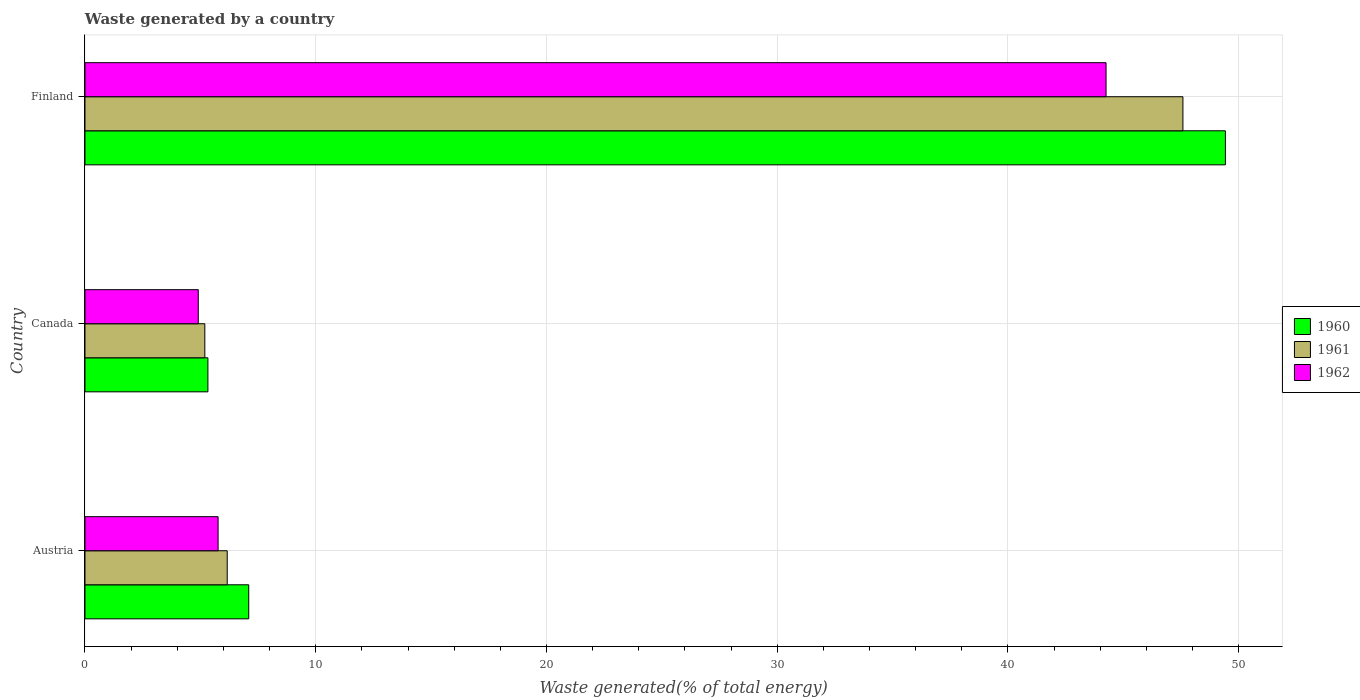How many different coloured bars are there?
Keep it short and to the point. 3. How many groups of bars are there?
Provide a succinct answer. 3. Are the number of bars on each tick of the Y-axis equal?
Your response must be concise. Yes. What is the label of the 3rd group of bars from the top?
Your answer should be very brief. Austria. In how many cases, is the number of bars for a given country not equal to the number of legend labels?
Give a very brief answer. 0. What is the total waste generated in 1960 in Finland?
Make the answer very short. 49.42. Across all countries, what is the maximum total waste generated in 1961?
Your answer should be very brief. 47.58. Across all countries, what is the minimum total waste generated in 1960?
Provide a succinct answer. 5.33. In which country was the total waste generated in 1960 maximum?
Your response must be concise. Finland. What is the total total waste generated in 1962 in the graph?
Offer a terse response. 54.93. What is the difference between the total waste generated in 1962 in Austria and that in Finland?
Keep it short and to the point. -38.48. What is the difference between the total waste generated in 1960 in Finland and the total waste generated in 1962 in Austria?
Offer a very short reply. 43.65. What is the average total waste generated in 1961 per country?
Your answer should be compact. 19.65. What is the difference between the total waste generated in 1962 and total waste generated in 1961 in Canada?
Your response must be concise. -0.28. What is the ratio of the total waste generated in 1961 in Canada to that in Finland?
Make the answer very short. 0.11. Is the total waste generated in 1962 in Canada less than that in Finland?
Provide a succinct answer. Yes. What is the difference between the highest and the second highest total waste generated in 1961?
Offer a very short reply. 41.42. What is the difference between the highest and the lowest total waste generated in 1961?
Ensure brevity in your answer.  42.39. In how many countries, is the total waste generated in 1962 greater than the average total waste generated in 1962 taken over all countries?
Your answer should be compact. 1. Is the sum of the total waste generated in 1962 in Austria and Finland greater than the maximum total waste generated in 1961 across all countries?
Keep it short and to the point. Yes. What does the 1st bar from the top in Finland represents?
Ensure brevity in your answer.  1962. Is it the case that in every country, the sum of the total waste generated in 1962 and total waste generated in 1960 is greater than the total waste generated in 1961?
Ensure brevity in your answer.  Yes. How many bars are there?
Offer a terse response. 9. Are all the bars in the graph horizontal?
Keep it short and to the point. Yes. How many countries are there in the graph?
Your answer should be compact. 3. What is the difference between two consecutive major ticks on the X-axis?
Your answer should be very brief. 10. Where does the legend appear in the graph?
Provide a succinct answer. Center right. How many legend labels are there?
Make the answer very short. 3. How are the legend labels stacked?
Ensure brevity in your answer.  Vertical. What is the title of the graph?
Provide a succinct answer. Waste generated by a country. Does "1972" appear as one of the legend labels in the graph?
Make the answer very short. No. What is the label or title of the X-axis?
Make the answer very short. Waste generated(% of total energy). What is the Waste generated(% of total energy) of 1960 in Austria?
Ensure brevity in your answer.  7.1. What is the Waste generated(% of total energy) in 1961 in Austria?
Provide a short and direct response. 6.16. What is the Waste generated(% of total energy) in 1962 in Austria?
Make the answer very short. 5.77. What is the Waste generated(% of total energy) of 1960 in Canada?
Your answer should be very brief. 5.33. What is the Waste generated(% of total energy) of 1961 in Canada?
Ensure brevity in your answer.  5.19. What is the Waste generated(% of total energy) of 1962 in Canada?
Your answer should be compact. 4.91. What is the Waste generated(% of total energy) in 1960 in Finland?
Your response must be concise. 49.42. What is the Waste generated(% of total energy) of 1961 in Finland?
Give a very brief answer. 47.58. What is the Waste generated(% of total energy) in 1962 in Finland?
Your answer should be very brief. 44.25. Across all countries, what is the maximum Waste generated(% of total energy) of 1960?
Make the answer very short. 49.42. Across all countries, what is the maximum Waste generated(% of total energy) of 1961?
Keep it short and to the point. 47.58. Across all countries, what is the maximum Waste generated(% of total energy) in 1962?
Offer a terse response. 44.25. Across all countries, what is the minimum Waste generated(% of total energy) of 1960?
Provide a succinct answer. 5.33. Across all countries, what is the minimum Waste generated(% of total energy) in 1961?
Offer a terse response. 5.19. Across all countries, what is the minimum Waste generated(% of total energy) in 1962?
Your answer should be compact. 4.91. What is the total Waste generated(% of total energy) in 1960 in the graph?
Give a very brief answer. 61.85. What is the total Waste generated(% of total energy) of 1961 in the graph?
Make the answer very short. 58.94. What is the total Waste generated(% of total energy) of 1962 in the graph?
Your answer should be very brief. 54.93. What is the difference between the Waste generated(% of total energy) in 1960 in Austria and that in Canada?
Your response must be concise. 1.77. What is the difference between the Waste generated(% of total energy) of 1961 in Austria and that in Canada?
Offer a terse response. 0.97. What is the difference between the Waste generated(% of total energy) in 1962 in Austria and that in Canada?
Ensure brevity in your answer.  0.86. What is the difference between the Waste generated(% of total energy) in 1960 in Austria and that in Finland?
Your answer should be very brief. -42.33. What is the difference between the Waste generated(% of total energy) in 1961 in Austria and that in Finland?
Keep it short and to the point. -41.42. What is the difference between the Waste generated(% of total energy) of 1962 in Austria and that in Finland?
Offer a terse response. -38.48. What is the difference between the Waste generated(% of total energy) in 1960 in Canada and that in Finland?
Offer a very short reply. -44.1. What is the difference between the Waste generated(% of total energy) in 1961 in Canada and that in Finland?
Provide a succinct answer. -42.39. What is the difference between the Waste generated(% of total energy) of 1962 in Canada and that in Finland?
Offer a very short reply. -39.34. What is the difference between the Waste generated(% of total energy) in 1960 in Austria and the Waste generated(% of total energy) in 1961 in Canada?
Make the answer very short. 1.9. What is the difference between the Waste generated(% of total energy) of 1960 in Austria and the Waste generated(% of total energy) of 1962 in Canada?
Offer a very short reply. 2.19. What is the difference between the Waste generated(% of total energy) in 1961 in Austria and the Waste generated(% of total energy) in 1962 in Canada?
Your response must be concise. 1.25. What is the difference between the Waste generated(% of total energy) of 1960 in Austria and the Waste generated(% of total energy) of 1961 in Finland?
Provide a succinct answer. -40.48. What is the difference between the Waste generated(% of total energy) of 1960 in Austria and the Waste generated(% of total energy) of 1962 in Finland?
Provide a short and direct response. -37.15. What is the difference between the Waste generated(% of total energy) of 1961 in Austria and the Waste generated(% of total energy) of 1962 in Finland?
Ensure brevity in your answer.  -38.09. What is the difference between the Waste generated(% of total energy) of 1960 in Canada and the Waste generated(% of total energy) of 1961 in Finland?
Your answer should be compact. -42.25. What is the difference between the Waste generated(% of total energy) in 1960 in Canada and the Waste generated(% of total energy) in 1962 in Finland?
Offer a terse response. -38.92. What is the difference between the Waste generated(% of total energy) of 1961 in Canada and the Waste generated(% of total energy) of 1962 in Finland?
Provide a succinct answer. -39.06. What is the average Waste generated(% of total energy) of 1960 per country?
Ensure brevity in your answer.  20.62. What is the average Waste generated(% of total energy) of 1961 per country?
Your answer should be very brief. 19.65. What is the average Waste generated(% of total energy) in 1962 per country?
Ensure brevity in your answer.  18.31. What is the difference between the Waste generated(% of total energy) in 1960 and Waste generated(% of total energy) in 1961 in Austria?
Make the answer very short. 0.93. What is the difference between the Waste generated(% of total energy) of 1960 and Waste generated(% of total energy) of 1962 in Austria?
Provide a short and direct response. 1.33. What is the difference between the Waste generated(% of total energy) of 1961 and Waste generated(% of total energy) of 1962 in Austria?
Offer a terse response. 0.4. What is the difference between the Waste generated(% of total energy) in 1960 and Waste generated(% of total energy) in 1961 in Canada?
Offer a terse response. 0.13. What is the difference between the Waste generated(% of total energy) of 1960 and Waste generated(% of total energy) of 1962 in Canada?
Ensure brevity in your answer.  0.42. What is the difference between the Waste generated(% of total energy) of 1961 and Waste generated(% of total energy) of 1962 in Canada?
Your answer should be compact. 0.28. What is the difference between the Waste generated(% of total energy) in 1960 and Waste generated(% of total energy) in 1961 in Finland?
Your response must be concise. 1.84. What is the difference between the Waste generated(% of total energy) of 1960 and Waste generated(% of total energy) of 1962 in Finland?
Make the answer very short. 5.17. What is the difference between the Waste generated(% of total energy) in 1961 and Waste generated(% of total energy) in 1962 in Finland?
Your answer should be compact. 3.33. What is the ratio of the Waste generated(% of total energy) in 1960 in Austria to that in Canada?
Your answer should be compact. 1.33. What is the ratio of the Waste generated(% of total energy) of 1961 in Austria to that in Canada?
Your response must be concise. 1.19. What is the ratio of the Waste generated(% of total energy) in 1962 in Austria to that in Canada?
Provide a succinct answer. 1.17. What is the ratio of the Waste generated(% of total energy) in 1960 in Austria to that in Finland?
Keep it short and to the point. 0.14. What is the ratio of the Waste generated(% of total energy) in 1961 in Austria to that in Finland?
Offer a terse response. 0.13. What is the ratio of the Waste generated(% of total energy) of 1962 in Austria to that in Finland?
Your answer should be very brief. 0.13. What is the ratio of the Waste generated(% of total energy) in 1960 in Canada to that in Finland?
Your answer should be compact. 0.11. What is the ratio of the Waste generated(% of total energy) in 1961 in Canada to that in Finland?
Your response must be concise. 0.11. What is the ratio of the Waste generated(% of total energy) in 1962 in Canada to that in Finland?
Keep it short and to the point. 0.11. What is the difference between the highest and the second highest Waste generated(% of total energy) of 1960?
Give a very brief answer. 42.33. What is the difference between the highest and the second highest Waste generated(% of total energy) in 1961?
Offer a very short reply. 41.42. What is the difference between the highest and the second highest Waste generated(% of total energy) of 1962?
Offer a terse response. 38.48. What is the difference between the highest and the lowest Waste generated(% of total energy) of 1960?
Your answer should be very brief. 44.1. What is the difference between the highest and the lowest Waste generated(% of total energy) of 1961?
Make the answer very short. 42.39. What is the difference between the highest and the lowest Waste generated(% of total energy) in 1962?
Offer a very short reply. 39.34. 